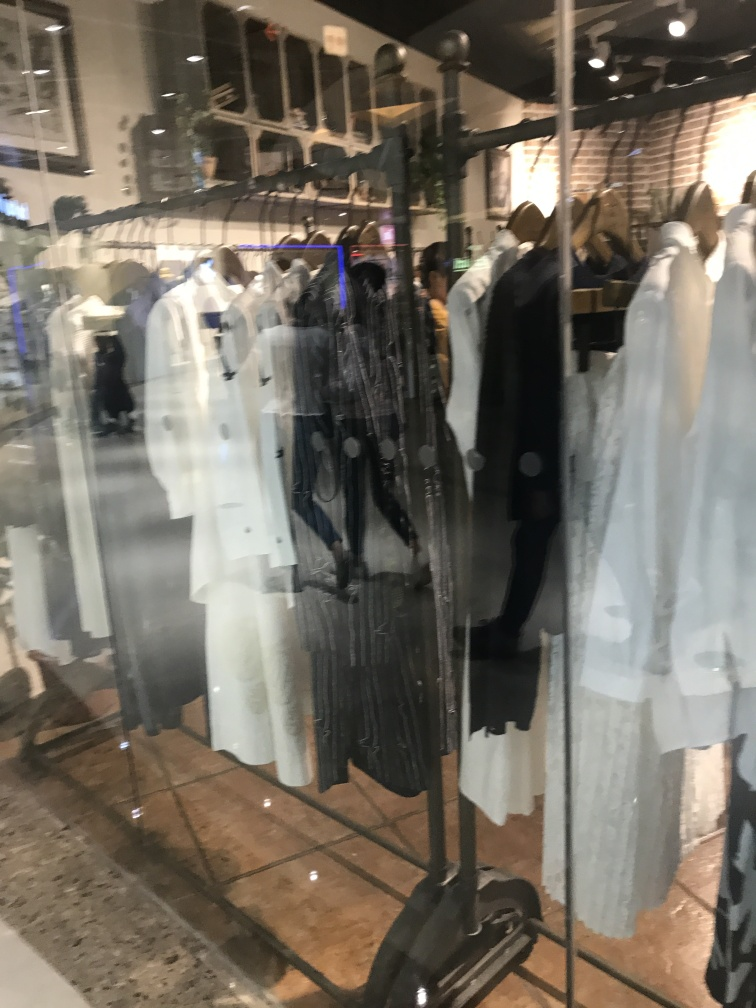Describe the ambiance or mood of this retail space as depicted in the photo. The ambiance of the retail space appears to be contemporary and chic, with bright lighting and an organized display that promotes a clean and modern aesthetic. The visible reflections and transparency through the glass also convey a bustling shopping environment, possibly within a mall or shopping center. 